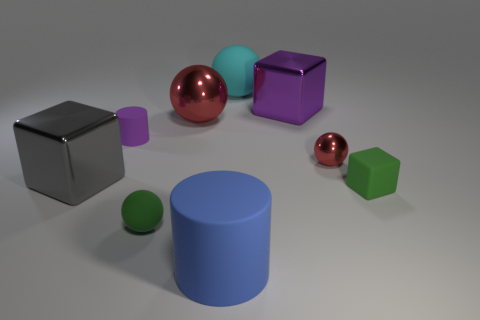How many things are tiny red shiny cubes or spheres to the left of the blue cylinder?
Give a very brief answer. 2. Is the color of the small rubber cylinder the same as the tiny shiny object?
Your response must be concise. No. Are there any green things made of the same material as the small purple cylinder?
Offer a very short reply. Yes. There is another matte object that is the same shape as the big cyan thing; what is its color?
Ensure brevity in your answer.  Green. Does the big cylinder have the same material as the large block in front of the tiny red ball?
Offer a very short reply. No. There is a red metal thing that is behind the purple cylinder that is behind the green sphere; what is its shape?
Keep it short and to the point. Sphere. There is a shiny sphere that is to the right of the blue thing; does it have the same size as the purple cylinder?
Your answer should be very brief. Yes. How many other objects are there of the same shape as the cyan matte thing?
Keep it short and to the point. 3. Is the color of the cube that is behind the gray thing the same as the big matte sphere?
Your answer should be very brief. No. Are there any tiny rubber things that have the same color as the big cylinder?
Keep it short and to the point. No. 